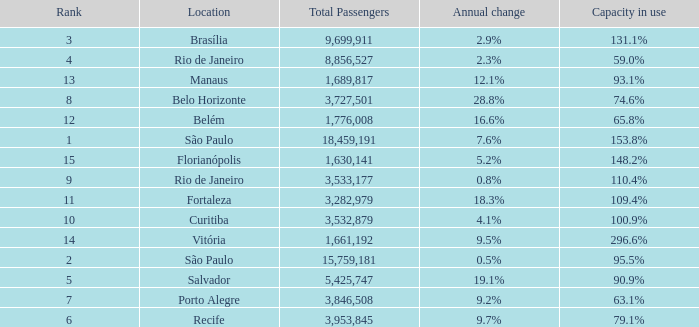What location has an annual change of 7.6% São Paulo. 